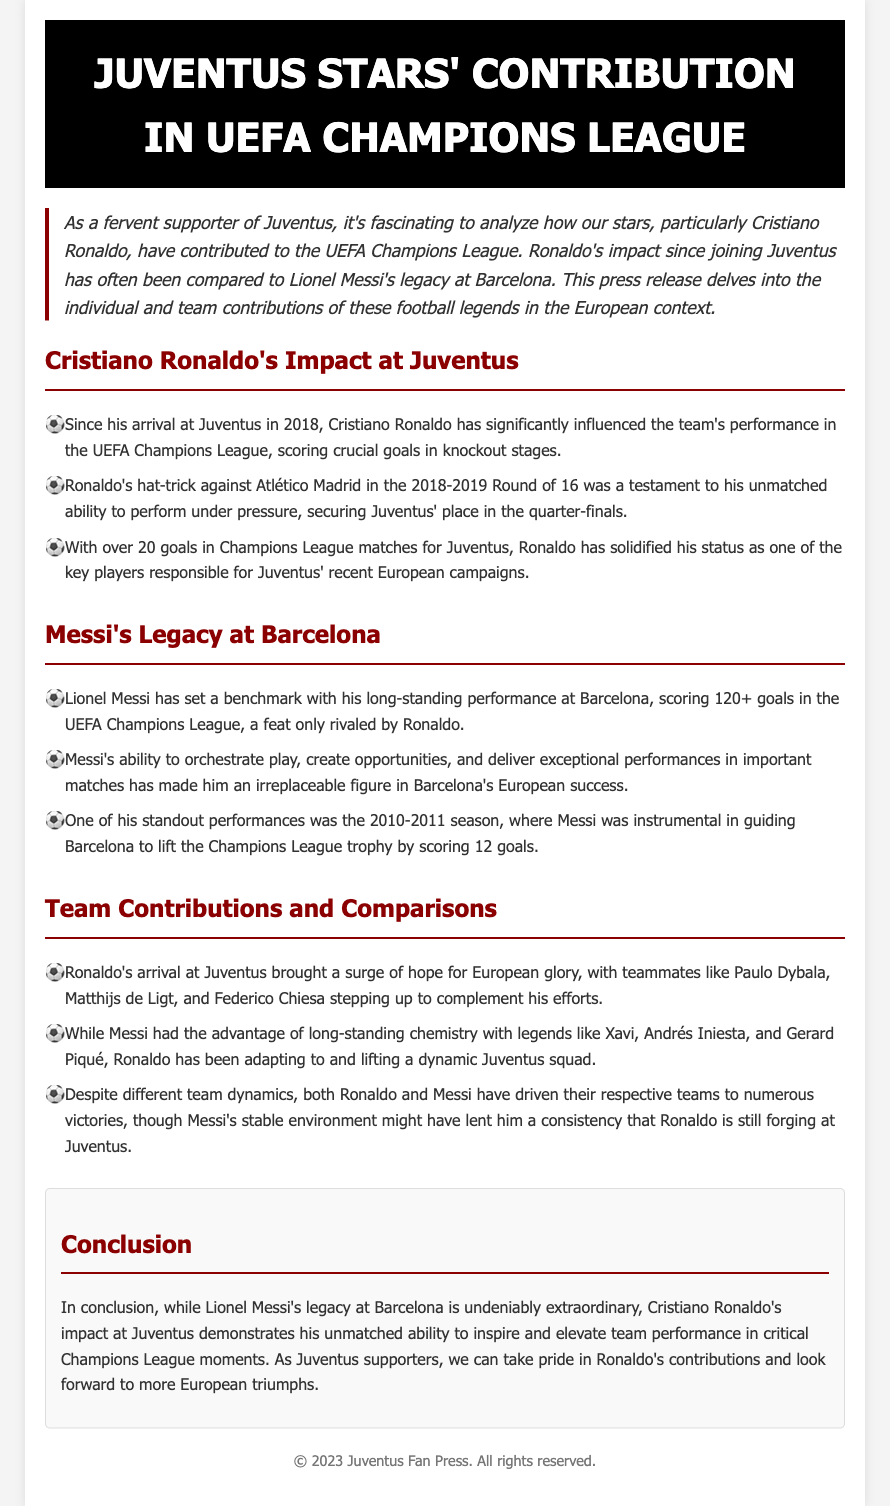What year did Ronaldo join Juventus? The document states that Cristiano Ronaldo joined Juventus in 2018.
Answer: 2018 How many goals did Ronaldo score in the Champions League for Juventus? The document mentions that Ronaldo has scored over 20 goals in Champions League matches for Juventus.
Answer: over 20 goals What significant performance did Ronaldo have against Atlético Madrid? The document highlights Ronaldo's hat-trick against Atlético Madrid in the 2018-2019 Round of 16 as a key moment.
Answer: hat-trick What is Messi's goal tally in the UEFA Champions League? The document indicates that Lionel Messi has scored 120+ goals in the UEFA Champions League.
Answer: 120+ goals How many goals did Messi score in the 2010-2011 season? The document states that Messi scored 12 goals during the 2010-2011 season.
Answer: 12 goals Which Juventus players were mentioned as complementing Ronaldo's efforts? The document lists Paulo Dybala, Matthijs de Ligt, and Federico Chiesa as teammates complementing Ronaldo.
Answer: Paulo Dybala, Matthijs de Ligt, Federico Chiesa What was Messi's advantage in terms of team chemistry? The document notes that Messi had long-standing chemistry with players like Xavi, Andrés Iniesta, and Gerard Piqué.
Answer: chemistry with Xavi, Andrés Iniesta, and Gerard Piqué Which team’s European glory did Ronaldo's arrival inspire hope for? The document indicates that Ronaldo's arrival brought hope for European glory for Juventus.
Answer: Juventus What does the conclusion highlight about Ronaldo's impact? The conclusion emphasizes Ronaldo's unmatched ability to inspire and elevate team performance in critical Champions League moments.
Answer: inspire and elevate team performance 